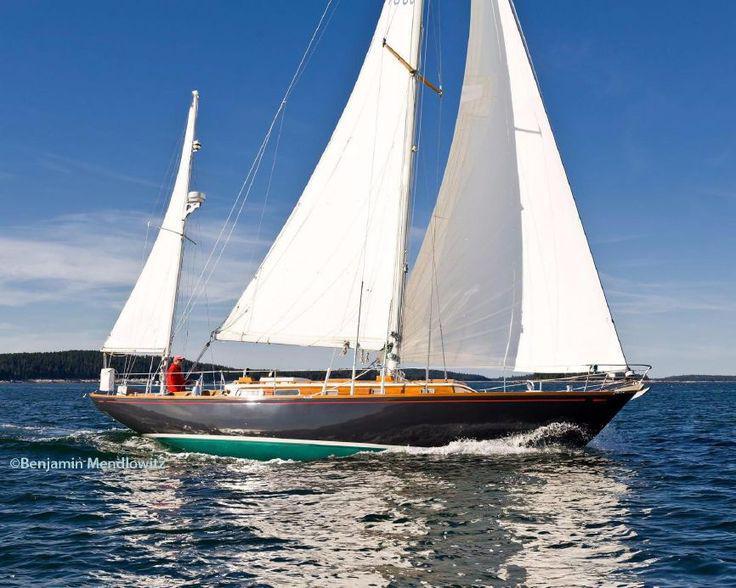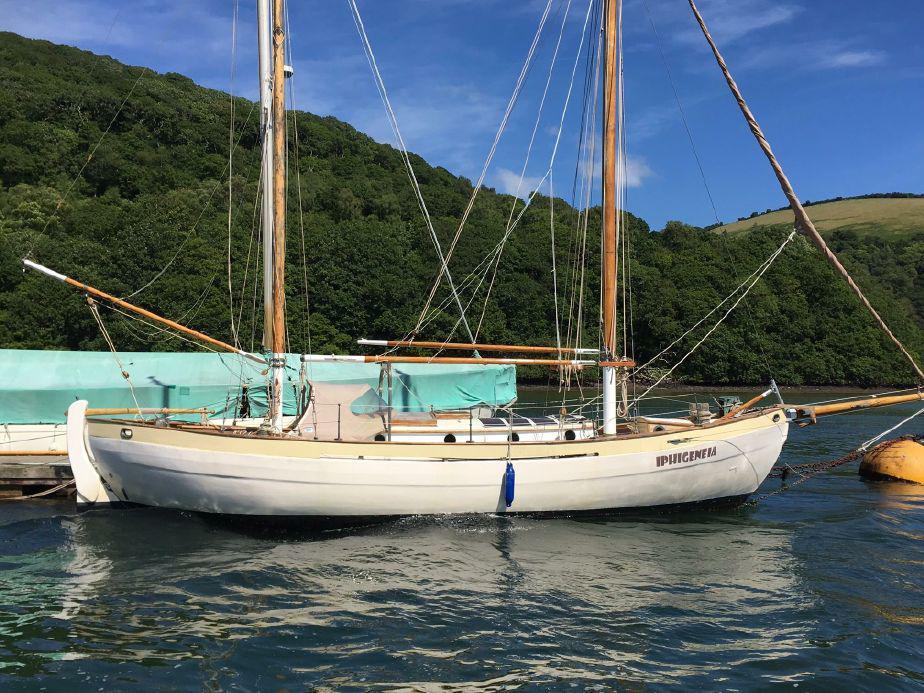The first image is the image on the left, the second image is the image on the right. Given the left and right images, does the statement "The left and right image contains a total of three boats." hold true? Answer yes or no. No. The first image is the image on the left, the second image is the image on the right. Given the left and right images, does the statement "One boat with a rider in a red jacket creates white spray as it moves through water with unfurled sails, while the other boat is still and has furled sails." hold true? Answer yes or no. Yes. 